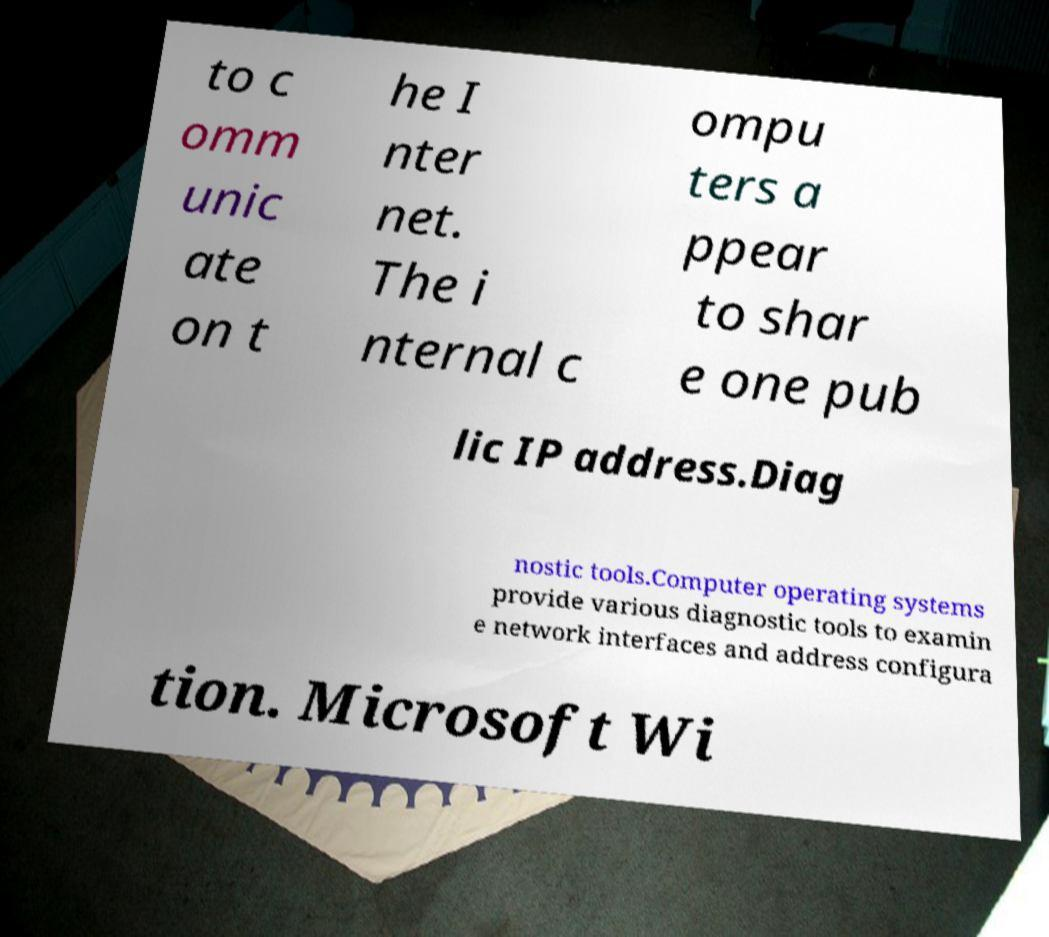What messages or text are displayed in this image? I need them in a readable, typed format. to c omm unic ate on t he I nter net. The i nternal c ompu ters a ppear to shar e one pub lic IP address.Diag nostic tools.Computer operating systems provide various diagnostic tools to examin e network interfaces and address configura tion. Microsoft Wi 